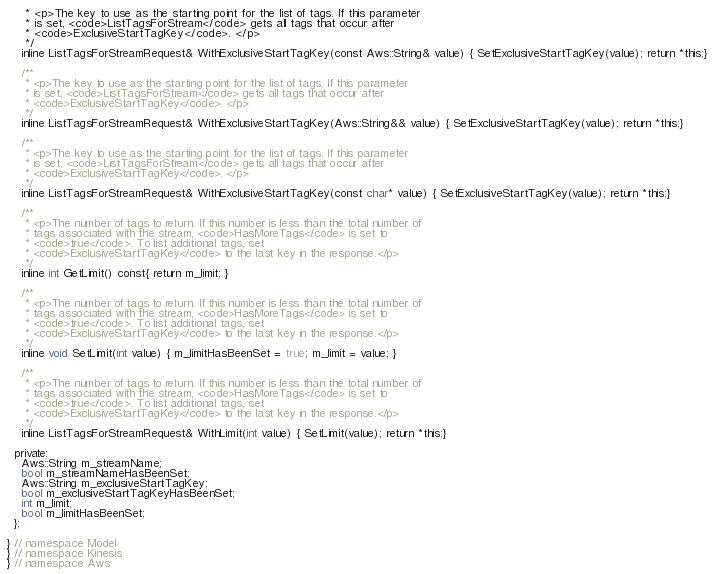Convert code to text. <code><loc_0><loc_0><loc_500><loc_500><_C_>     * <p>The key to use as the starting point for the list of tags. If this parameter
     * is set, <code>ListTagsForStream</code> gets all tags that occur after
     * <code>ExclusiveStartTagKey</code>. </p>
     */
    inline ListTagsForStreamRequest& WithExclusiveStartTagKey(const Aws::String& value) { SetExclusiveStartTagKey(value); return *this;}

    /**
     * <p>The key to use as the starting point for the list of tags. If this parameter
     * is set, <code>ListTagsForStream</code> gets all tags that occur after
     * <code>ExclusiveStartTagKey</code>. </p>
     */
    inline ListTagsForStreamRequest& WithExclusiveStartTagKey(Aws::String&& value) { SetExclusiveStartTagKey(value); return *this;}

    /**
     * <p>The key to use as the starting point for the list of tags. If this parameter
     * is set, <code>ListTagsForStream</code> gets all tags that occur after
     * <code>ExclusiveStartTagKey</code>. </p>
     */
    inline ListTagsForStreamRequest& WithExclusiveStartTagKey(const char* value) { SetExclusiveStartTagKey(value); return *this;}

    /**
     * <p>The number of tags to return. If this number is less than the total number of
     * tags associated with the stream, <code>HasMoreTags</code> is set to
     * <code>true</code>. To list additional tags, set
     * <code>ExclusiveStartTagKey</code> to the last key in the response.</p>
     */
    inline int GetLimit() const{ return m_limit; }

    /**
     * <p>The number of tags to return. If this number is less than the total number of
     * tags associated with the stream, <code>HasMoreTags</code> is set to
     * <code>true</code>. To list additional tags, set
     * <code>ExclusiveStartTagKey</code> to the last key in the response.</p>
     */
    inline void SetLimit(int value) { m_limitHasBeenSet = true; m_limit = value; }

    /**
     * <p>The number of tags to return. If this number is less than the total number of
     * tags associated with the stream, <code>HasMoreTags</code> is set to
     * <code>true</code>. To list additional tags, set
     * <code>ExclusiveStartTagKey</code> to the last key in the response.</p>
     */
    inline ListTagsForStreamRequest& WithLimit(int value) { SetLimit(value); return *this;}

  private:
    Aws::String m_streamName;
    bool m_streamNameHasBeenSet;
    Aws::String m_exclusiveStartTagKey;
    bool m_exclusiveStartTagKeyHasBeenSet;
    int m_limit;
    bool m_limitHasBeenSet;
  };

} // namespace Model
} // namespace Kinesis
} // namespace Aws
</code> 